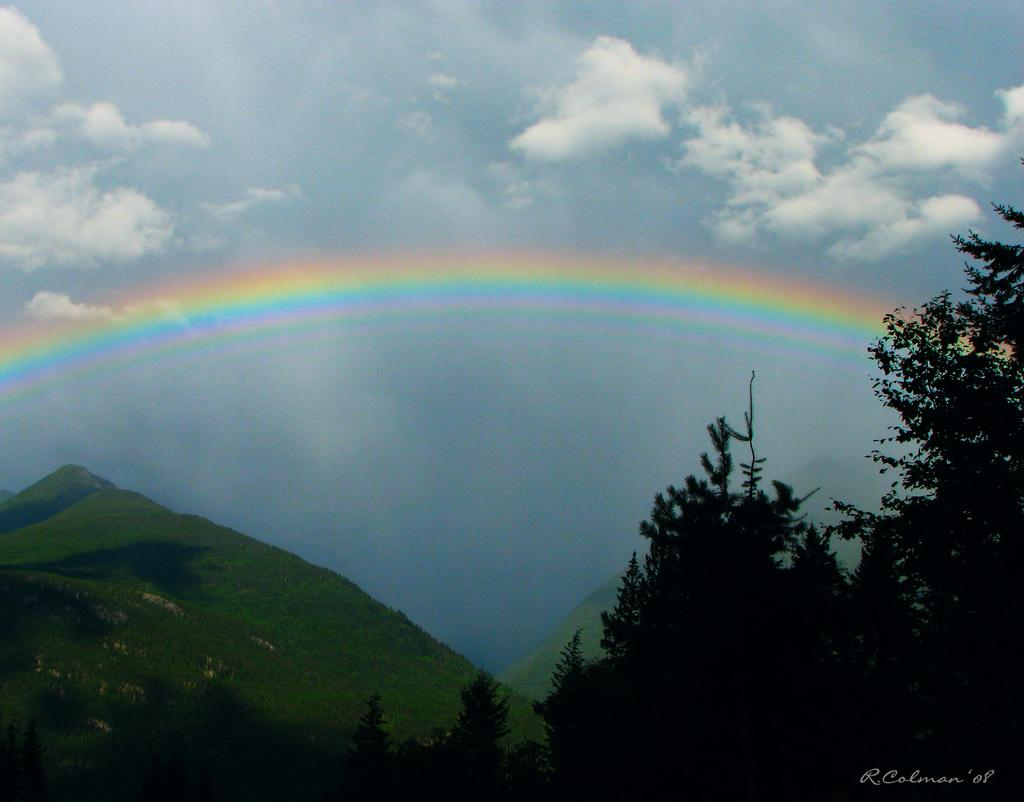What type of landscape feature can be seen in the image? There are hills in the image. What type of vegetation is present in the image? There are trees in the image. What can be seen in the sky in the image? There is a rainbow in the sky, and clouds are also visible. How many potatoes can be seen growing on the hills in the image? There are no potatoes visible in the image; it features hills, trees, and a sky with a rainbow and clouds. Is there a spy observing the scene from a hidden location in the image? There is no indication of a spy or any hidden location in the image. 